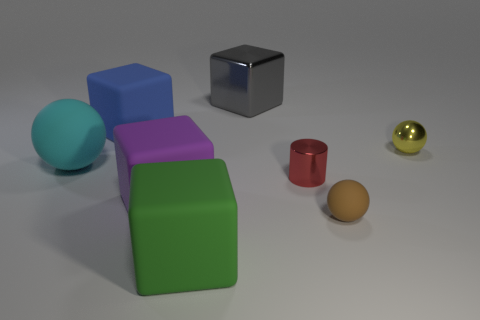Subtract all large metallic cubes. How many cubes are left? 3 Add 1 green cylinders. How many objects exist? 9 Subtract all purple cubes. How many cubes are left? 3 Subtract all gray balls. Subtract all red cylinders. How many balls are left? 3 Subtract 0 blue spheres. How many objects are left? 8 Subtract all spheres. How many objects are left? 5 Subtract all big brown shiny cylinders. Subtract all tiny balls. How many objects are left? 6 Add 3 metal cylinders. How many metal cylinders are left? 4 Add 2 large rubber cubes. How many large rubber cubes exist? 5 